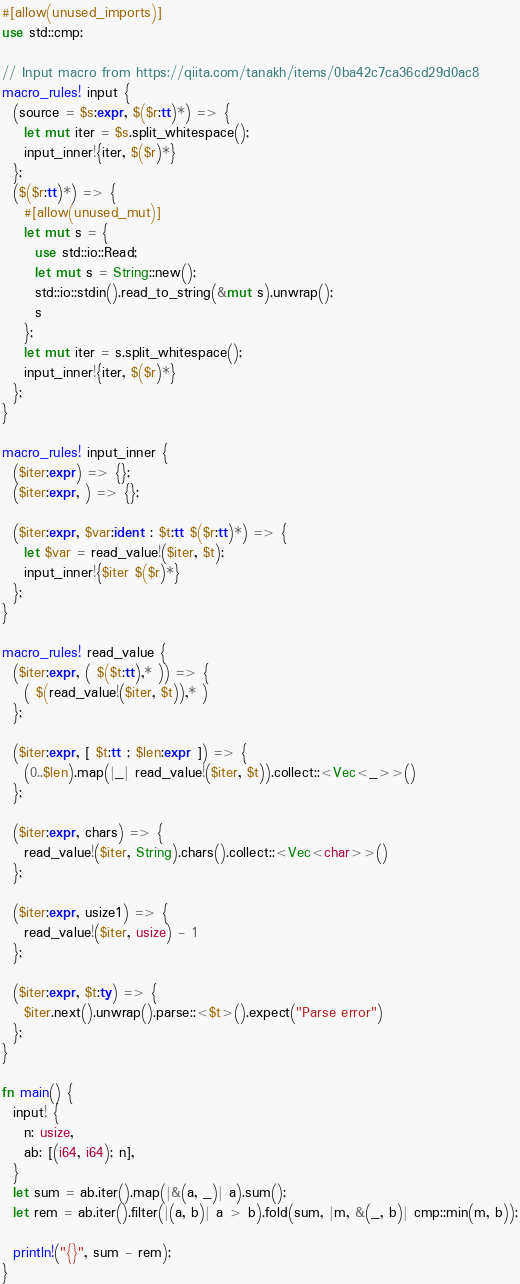<code> <loc_0><loc_0><loc_500><loc_500><_Rust_>#[allow(unused_imports)]
use std::cmp;

// Input macro from https://qiita.com/tanakh/items/0ba42c7ca36cd29d0ac8
macro_rules! input {
  (source = $s:expr, $($r:tt)*) => {
    let mut iter = $s.split_whitespace();
    input_inner!{iter, $($r)*}
  };
  ($($r:tt)*) => {
    #[allow(unused_mut)]
    let mut s = {
      use std::io::Read;
      let mut s = String::new();
      std::io::stdin().read_to_string(&mut s).unwrap();
      s
    };
    let mut iter = s.split_whitespace();
    input_inner!{iter, $($r)*}
  };
}

macro_rules! input_inner {
  ($iter:expr) => {};
  ($iter:expr, ) => {};

  ($iter:expr, $var:ident : $t:tt $($r:tt)*) => {
    let $var = read_value!($iter, $t);
    input_inner!{$iter $($r)*}
  };
}

macro_rules! read_value {
  ($iter:expr, ( $($t:tt),* )) => {
    ( $(read_value!($iter, $t)),* )
  };

  ($iter:expr, [ $t:tt ; $len:expr ]) => {
    (0..$len).map(|_| read_value!($iter, $t)).collect::<Vec<_>>()
  };

  ($iter:expr, chars) => {
    read_value!($iter, String).chars().collect::<Vec<char>>()
  };

  ($iter:expr, usize1) => {
    read_value!($iter, usize) - 1
  };

  ($iter:expr, $t:ty) => {
    $iter.next().unwrap().parse::<$t>().expect("Parse error")
  };
}

fn main() {
  input! {
    n: usize,
    ab: [(i64, i64); n],
  }
  let sum = ab.iter().map(|&(a, _)| a).sum();
  let rem = ab.iter().filter(|(a, b)| a > b).fold(sum, |m, &(_, b)| cmp::min(m, b));

  println!("{}", sum - rem);
}
</code> 